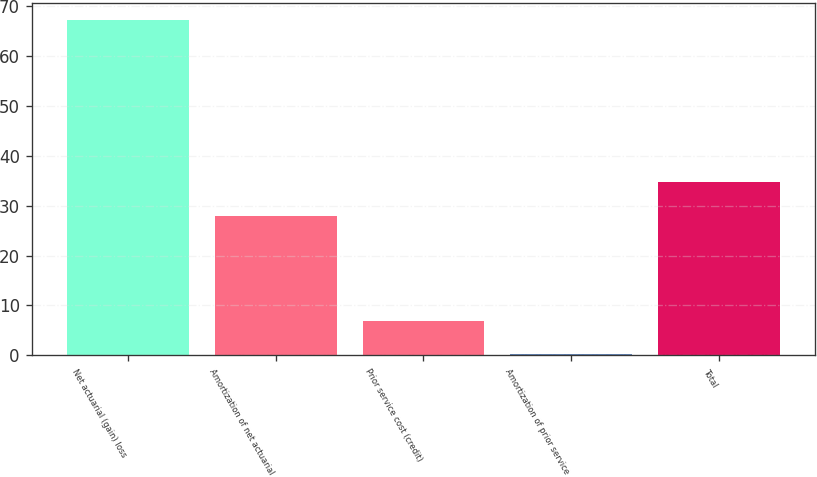Convert chart. <chart><loc_0><loc_0><loc_500><loc_500><bar_chart><fcel>Net actuarial (gain) loss<fcel>Amortization of net actuarial<fcel>Prior service cost (credit)<fcel>Amortization of prior service<fcel>Total<nl><fcel>67.2<fcel>27.9<fcel>6.9<fcel>0.2<fcel>34.7<nl></chart> 